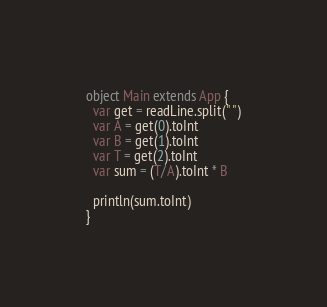<code> <loc_0><loc_0><loc_500><loc_500><_Scala_>object Main extends App {
  var get = readLine.split(" ")
  var A = get(0).toInt
  var B = get(1).toInt
  var T = get(2).toInt
  var sum = (T/A).toInt * B
  
  println(sum.toInt)
}</code> 